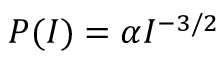<formula> <loc_0><loc_0><loc_500><loc_500>P ( I ) = \alpha I ^ { - 3 / 2 }</formula> 